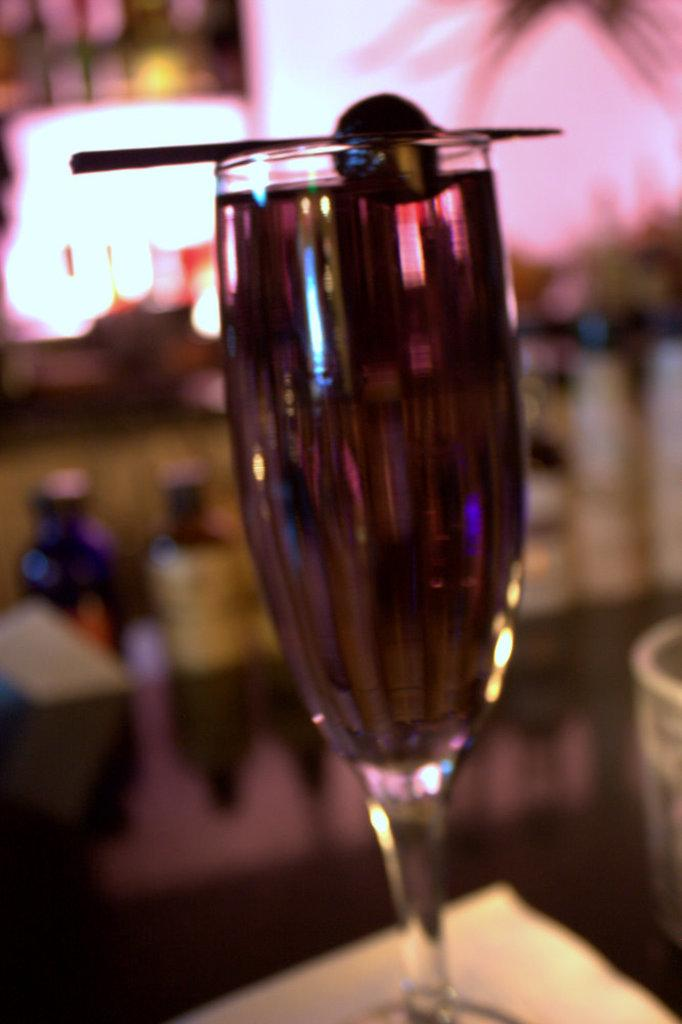What object is visible in the image? There is a glass in the image. Where is the glass located? The glass is placed on a table. Can you describe the background of the image? The background of the image is blurred. What type of card is being played in the image? There is no card or any indication of a game being played in the image; it only features a glass on a table with a blurred background. 